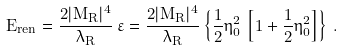<formula> <loc_0><loc_0><loc_500><loc_500>E _ { r e n } = \frac { 2 | M _ { R } | ^ { 4 } } { \lambda _ { R } } \, \varepsilon = \frac { 2 | M _ { R } | ^ { 4 } } { \lambda _ { R } } \left \{ \frac { 1 } { 2 } \eta _ { 0 } ^ { 2 } \, \left [ 1 + \frac { 1 } { 2 } \eta _ { 0 } ^ { 2 } \right ] \right \} \, .</formula> 